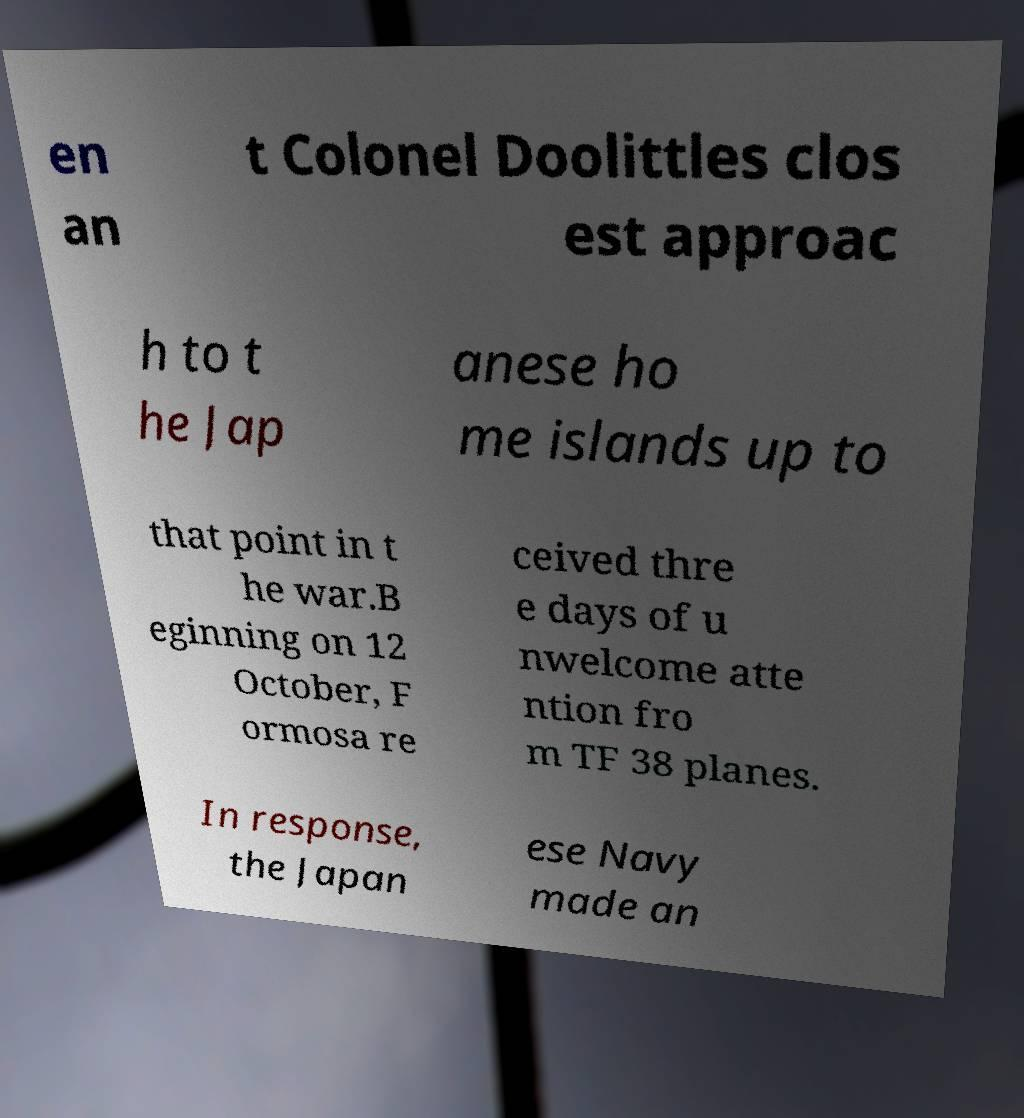Could you extract and type out the text from this image? en an t Colonel Doolittles clos est approac h to t he Jap anese ho me islands up to that point in t he war.B eginning on 12 October, F ormosa re ceived thre e days of u nwelcome atte ntion fro m TF 38 planes. In response, the Japan ese Navy made an 